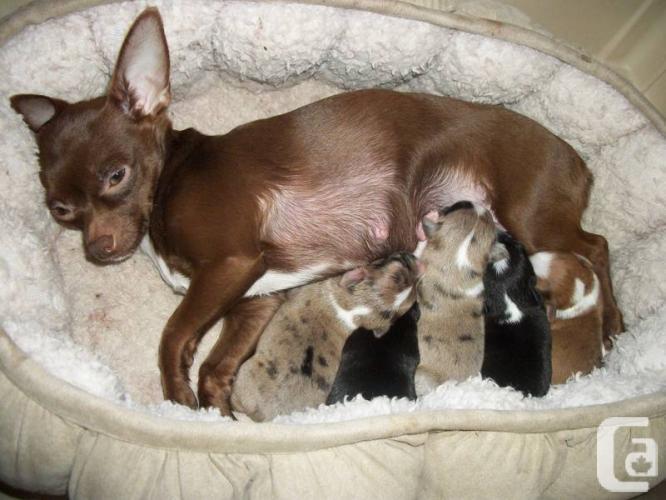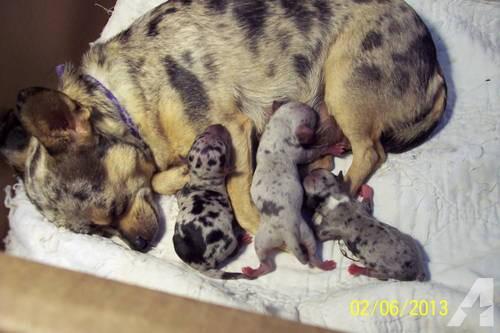The first image is the image on the left, the second image is the image on the right. Evaluate the accuracy of this statement regarding the images: "There are two chihuahua puppies". Is it true? Answer yes or no. No. The first image is the image on the left, the second image is the image on the right. For the images displayed, is the sentence "A human hand is touching a small dog in one image." factually correct? Answer yes or no. No. 